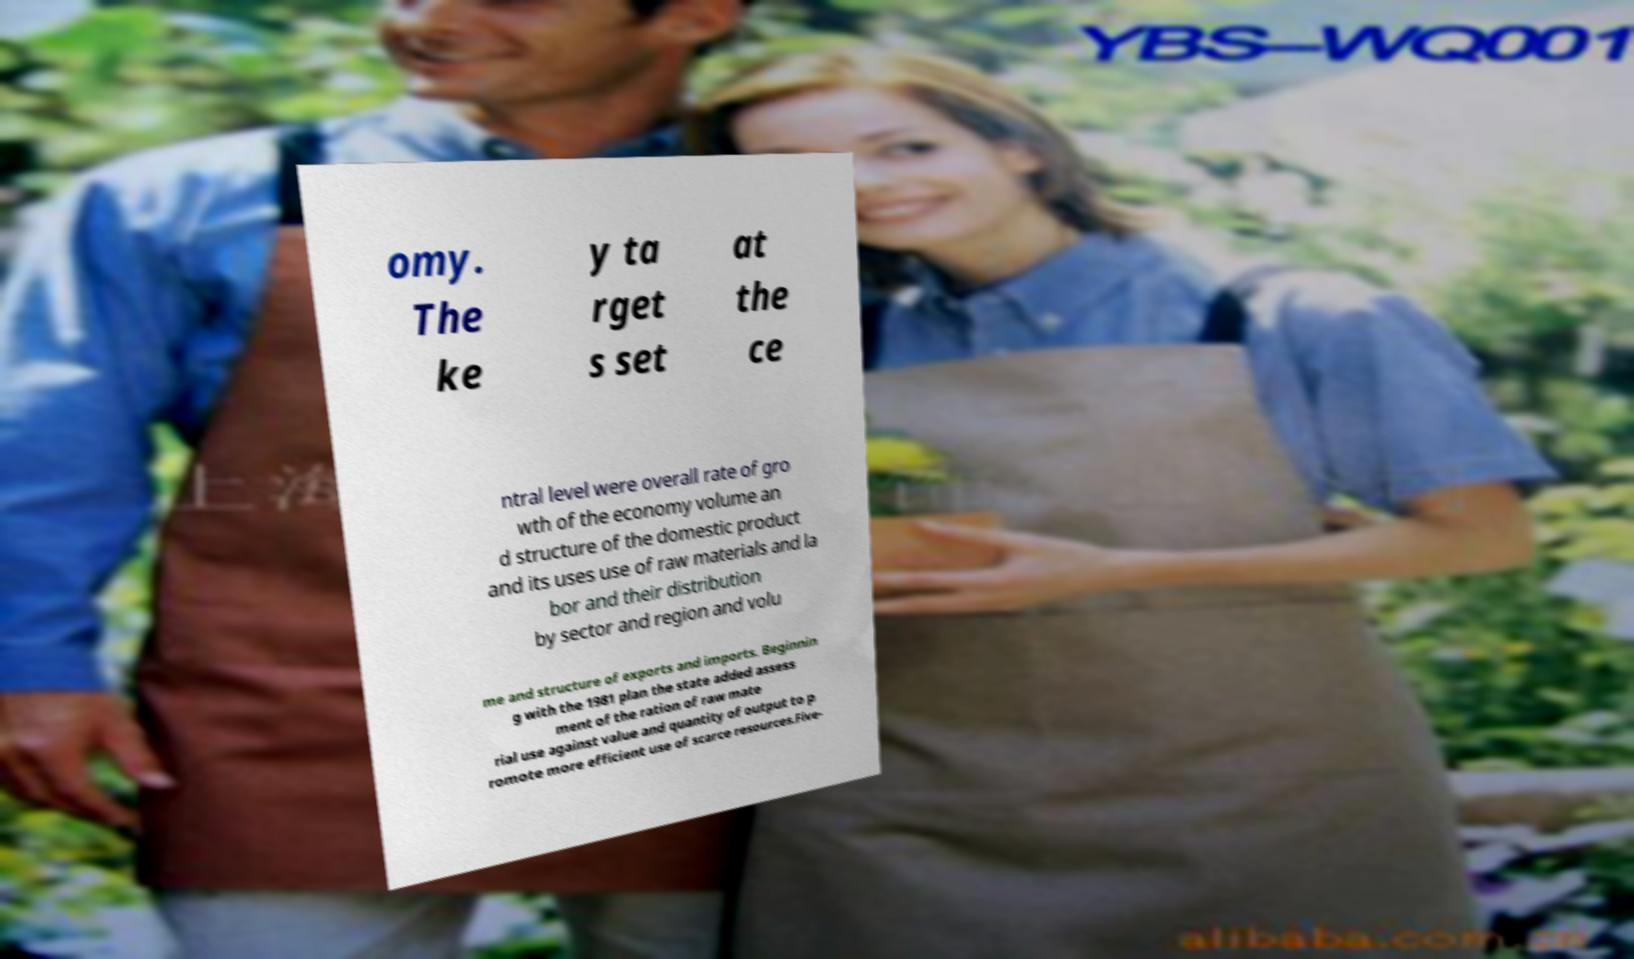Can you read and provide the text displayed in the image?This photo seems to have some interesting text. Can you extract and type it out for me? omy. The ke y ta rget s set at the ce ntral level were overall rate of gro wth of the economy volume an d structure of the domestic product and its uses use of raw materials and la bor and their distribution by sector and region and volu me and structure of exports and imports. Beginnin g with the 1981 plan the state added assess ment of the ration of raw mate rial use against value and quantity of output to p romote more efficient use of scarce resources.Five- 